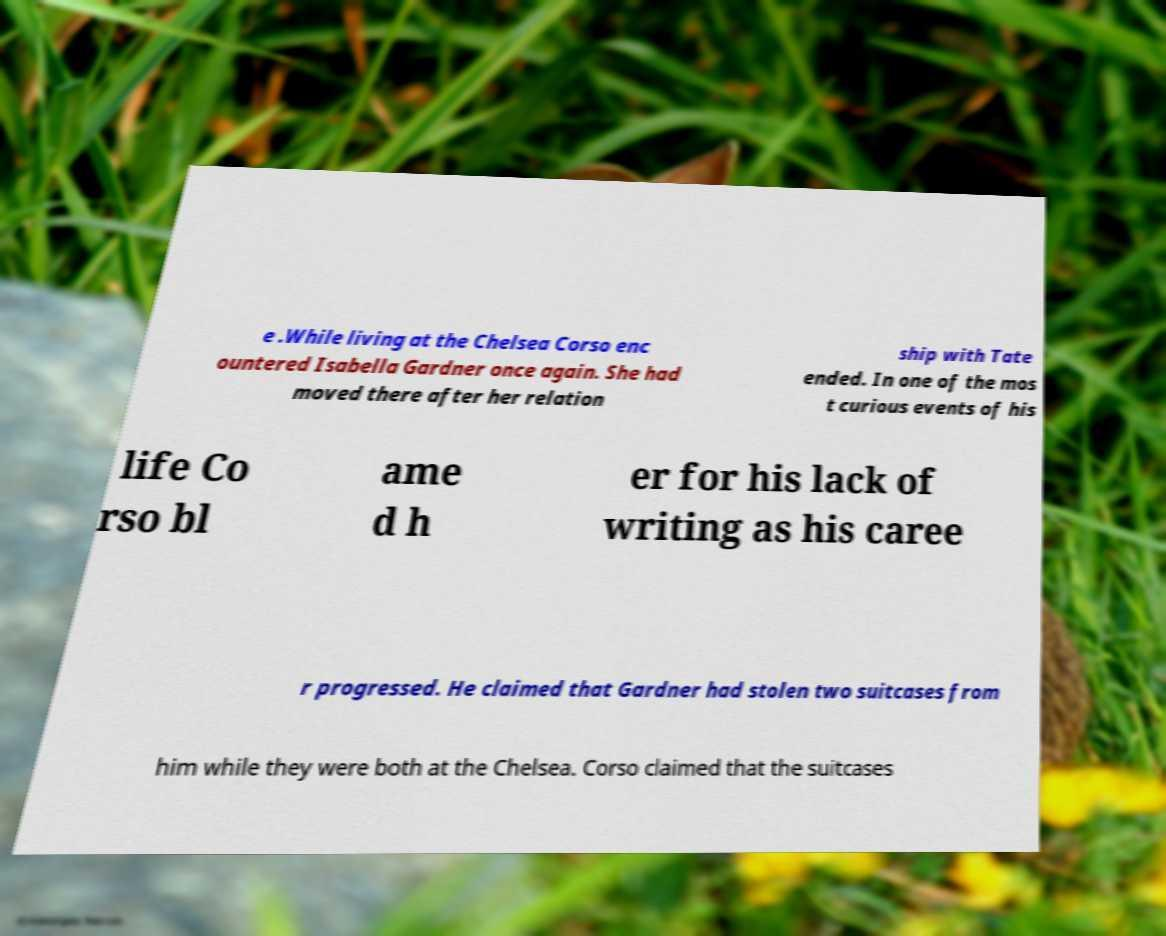Can you accurately transcribe the text from the provided image for me? e .While living at the Chelsea Corso enc ountered Isabella Gardner once again. She had moved there after her relation ship with Tate ended. In one of the mos t curious events of his life Co rso bl ame d h er for his lack of writing as his caree r progressed. He claimed that Gardner had stolen two suitcases from him while they were both at the Chelsea. Corso claimed that the suitcases 